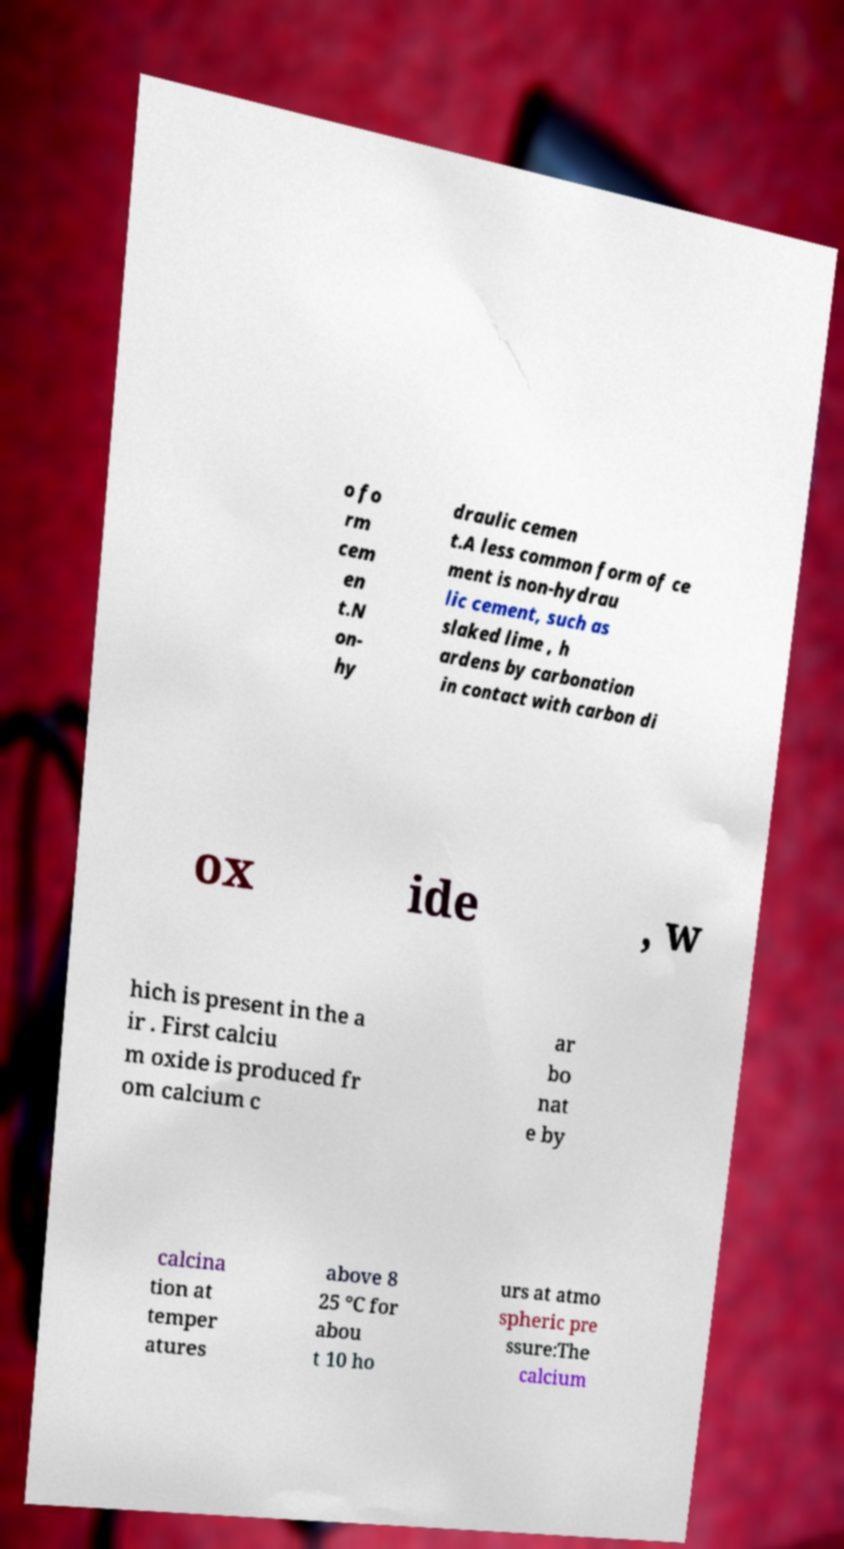Could you assist in decoding the text presented in this image and type it out clearly? o fo rm cem en t.N on- hy draulic cemen t.A less common form of ce ment is non-hydrau lic cement, such as slaked lime , h ardens by carbonation in contact with carbon di ox ide , w hich is present in the a ir . First calciu m oxide is produced fr om calcium c ar bo nat e by calcina tion at temper atures above 8 25 °C for abou t 10 ho urs at atmo spheric pre ssure:The calcium 